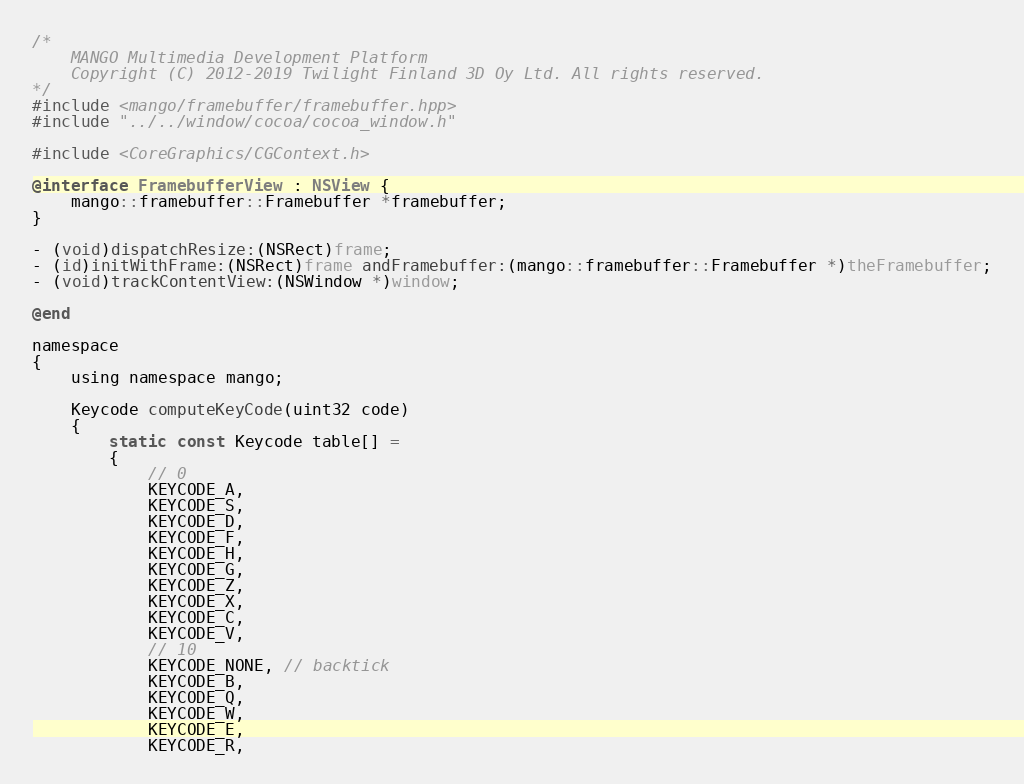Convert code to text. <code><loc_0><loc_0><loc_500><loc_500><_ObjectiveC_>/*
    MANGO Multimedia Development Platform
    Copyright (C) 2012-2019 Twilight Finland 3D Oy Ltd. All rights reserved.
*/
#include <mango/framebuffer/framebuffer.hpp>
#include "../../window/cocoa/cocoa_window.h"

#include <CoreGraphics/CGContext.h>

@interface FramebufferView : NSView {
    mango::framebuffer::Framebuffer *framebuffer;
}

- (void)dispatchResize:(NSRect)frame;
- (id)initWithFrame:(NSRect)frame andFramebuffer:(mango::framebuffer::Framebuffer *)theFramebuffer;
- (void)trackContentView:(NSWindow *)window;

@end

namespace
{
    using namespace mango;

    Keycode computeKeyCode(uint32 code)
    {
        static const Keycode table[] =
        {
            // 0
            KEYCODE_A,
            KEYCODE_S,
            KEYCODE_D,
            KEYCODE_F,
            KEYCODE_H,
            KEYCODE_G,
            KEYCODE_Z,
            KEYCODE_X,
            KEYCODE_C,
            KEYCODE_V,
            // 10
            KEYCODE_NONE, // backtick
            KEYCODE_B,
            KEYCODE_Q,
            KEYCODE_W,
            KEYCODE_E,
            KEYCODE_R,</code> 